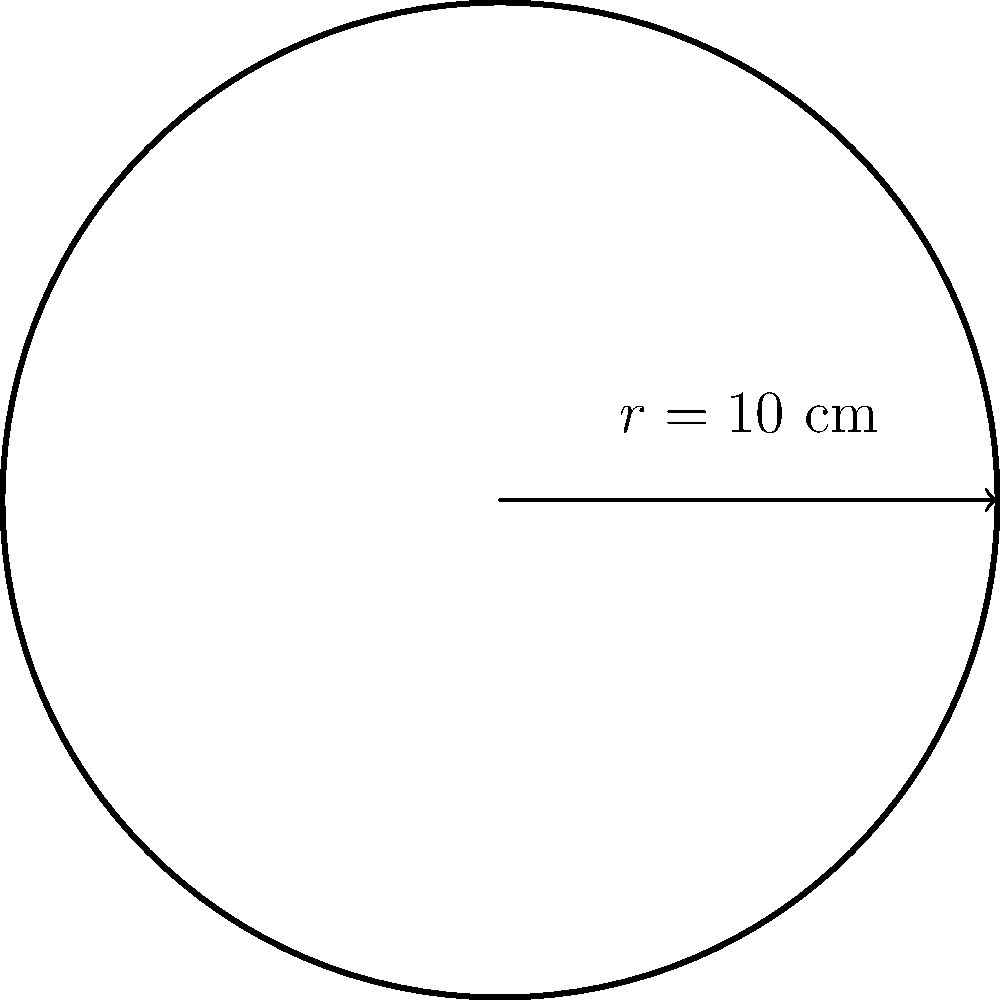As a drummer in our collaborative music project, you need to calculate the area of a circular drumhead. If the radius of the drumhead is 10 cm, what is its area in square centimeters? (Use $\pi \approx 3.14$) To find the area of a circular drumhead, we need to use the formula for the area of a circle:

1. The formula for the area of a circle is $A = \pi r^2$, where $A$ is the area and $r$ is the radius.

2. We are given that the radius $r = 10$ cm and $\pi \approx 3.14$.

3. Let's substitute these values into the formula:
   $A = \pi r^2 = 3.14 \times 10^2$

4. Calculate $10^2$:
   $A = 3.14 \times 100$

5. Multiply:
   $A = 314$ cm²

Therefore, the area of the drumhead is 314 square centimeters.
Answer: 314 cm² 